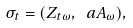Convert formula to latex. <formula><loc_0><loc_0><loc_500><loc_500>\sigma _ { t } = ( Z _ { t \omega } , \ a A _ { \omega } ) ,</formula> 